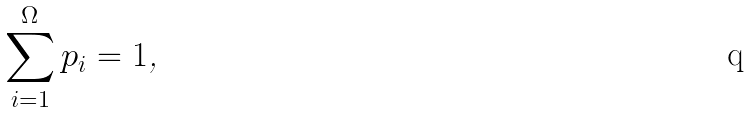Convert formula to latex. <formula><loc_0><loc_0><loc_500><loc_500>\sum _ { i = 1 } ^ { \Omega } p _ { i } = 1 \text {,}</formula> 